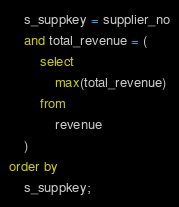<code> <loc_0><loc_0><loc_500><loc_500><_SQL_>	s_suppkey = supplier_no
	and total_revenue = (
		select
			max(total_revenue)
		from
			revenue
	)
order by
	s_suppkey;
</code> 